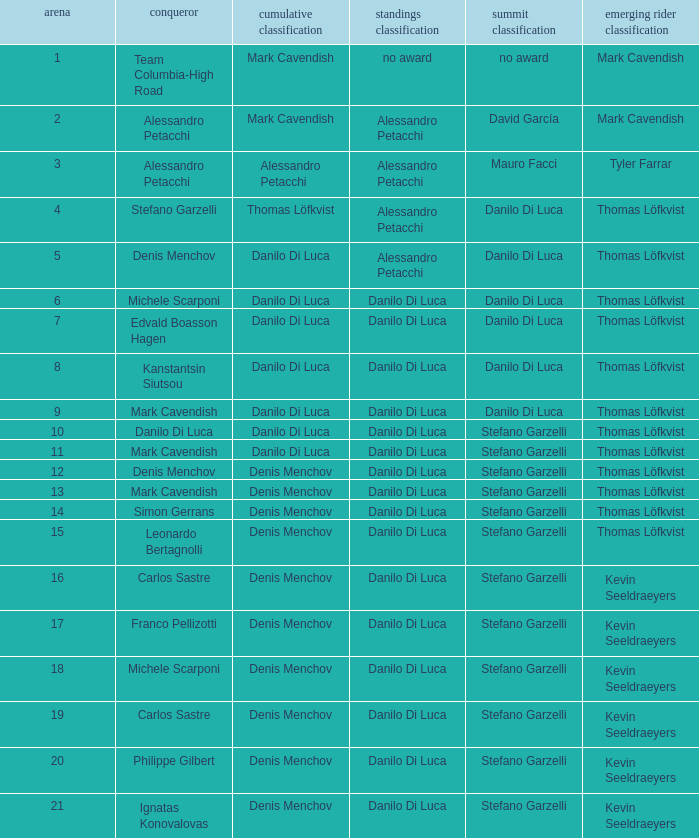When 19 is the stage who is the points classification? Danilo Di Luca. 